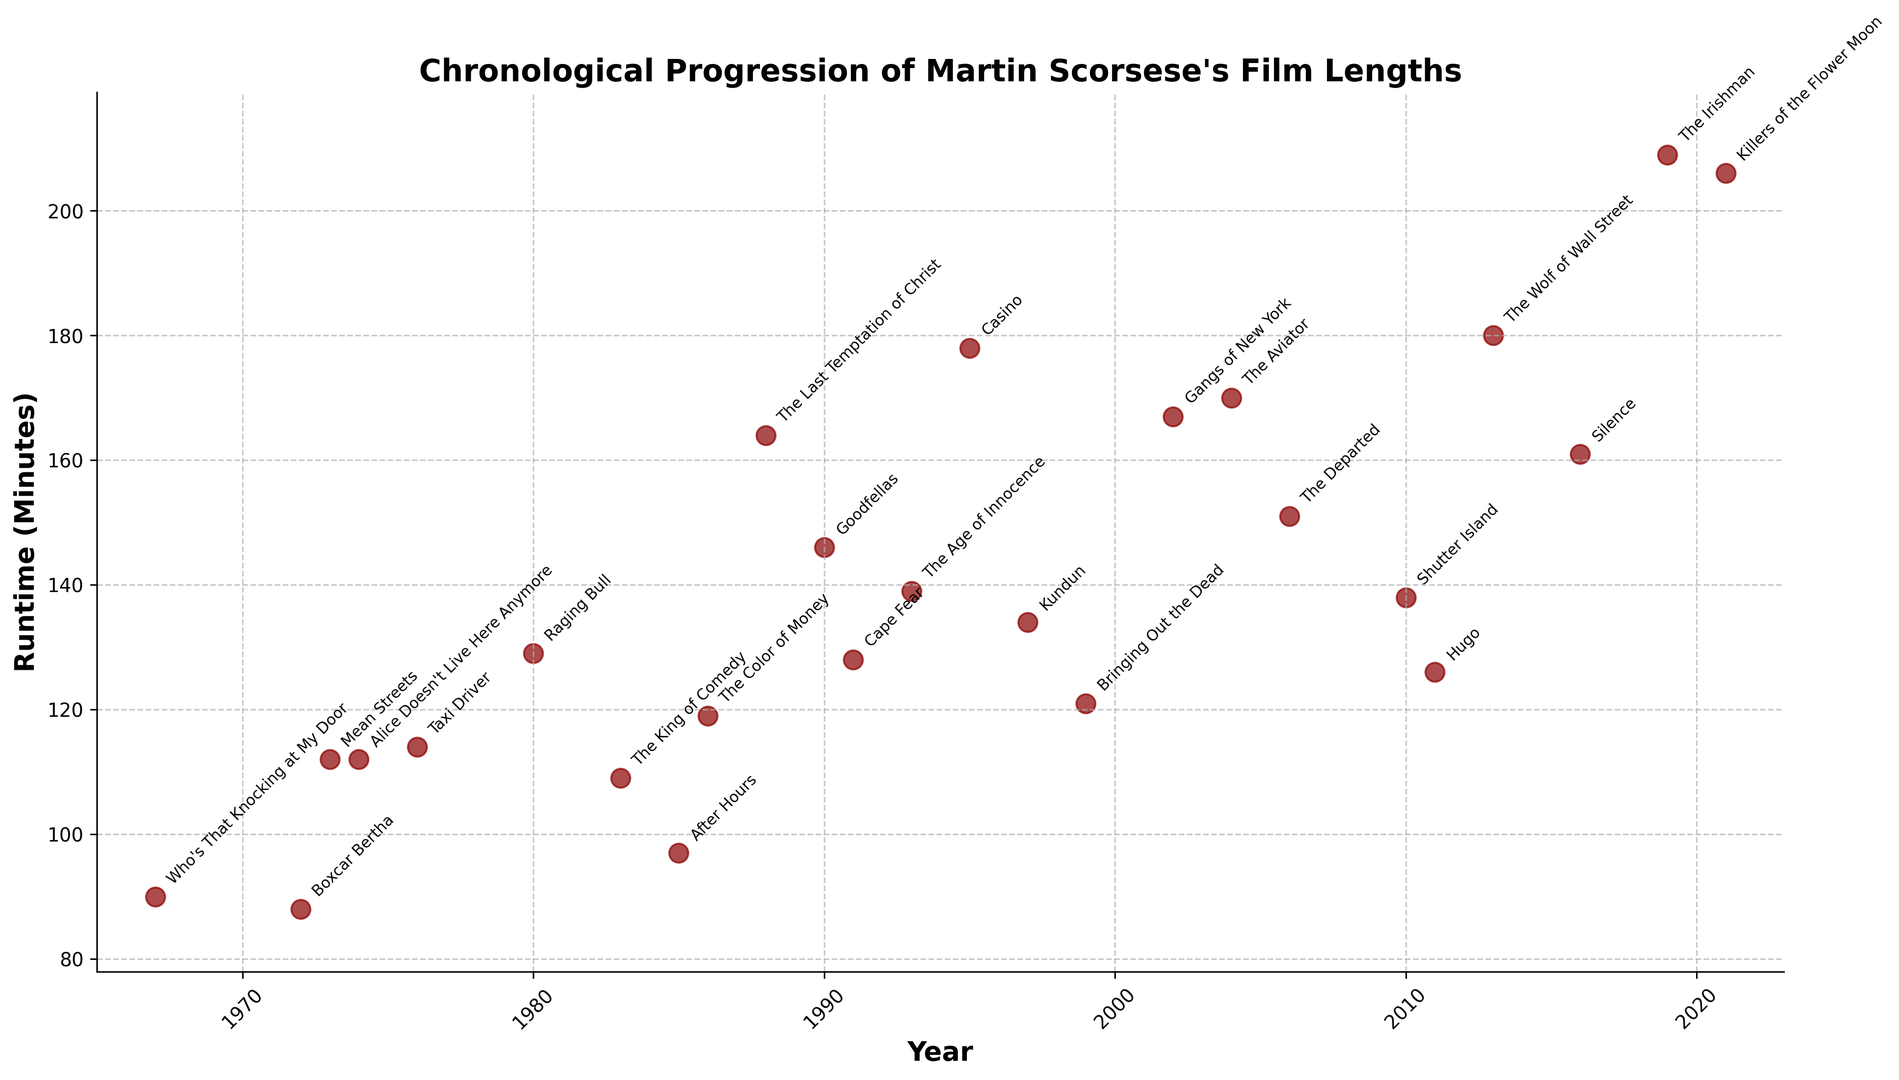Which Scorsese film has the longest runtime? Identify the tallest point on the plot corresponding to the film with the highest runtime. The film with the highest runtime is annotated as "The Irishman" with 209 minutes.
Answer: The Irishman Which film directed by Scorsese in the 1980s has the shortest runtime, and what is its duration? Look at the years in the 1980s, observe the scatter plot points in those years, and identify the shortest runtime. The film "After Hours" directed in 1985 has a runtime of 97 minutes.
Answer: After Hours, 97 minutes What is the difference in runtime between "Mean Streets" and "Taxi Driver"? Find the points corresponding to "Mean Streets" (1973) and "Taxi Driver" (1976), then subtract the former's runtime (112 minutes) from the latter's runtime (114 minutes). The difference is 2 minutes.
Answer: 2 minutes Which film has a longer runtime, "Goodfellas" or "Casino"? By how much? Identify the points corresponding to "Goodfellas" (1990) and "Casino" (1995), then compare their runtimes. "Goodfellas" has a runtime of 146 minutes, and "Casino" has 178 minutes. The difference is 32 minutes.
Answer: Casino by 32 minutes How did Scorsese's film runtimes trend from the 1990s to the 2000s? Examine the runtime points for the films from the 1990s and the 2000s. The trend shows a general increase in runtimes, with films like "Casino" (178 minutes) and "Gangs of New York" (167 minutes) compared to earlier films in the 1990s.
Answer: Increasing trend What is the average runtime of Scorsese's movies in the 2010s? Identify films released in the 2010s ("Shutter Island," "Hugo," "The Wolf of Wall Street," "Silence," and "The Irishman"), sum their runtimes (138 + 126 + 180 + 161 + 209) = 814, and divide by the number of films (5). The average is 814/5 = 162.8 minutes.
Answer: 162.8 minutes Compare the runtimes of "The Aviator" and "The Departed." Which one is longer and by how much? Find the points for "The Aviator" (2004, 170 minutes) and "The Departed" (2006, 151 minutes), compare their runtimes. The difference is 170 - 151 = 19 minutes.
Answer: The Aviator by 19 minutes Is there a film directed by Scorsese that is shorter than 100 minutes? If so, name it. Look for points with runtimes less than 100 minutes and check their annotations. The film "After Hours" (1985) has a runtime of 97 minutes.
Answer: After Hours Which decade saw the highest average runtime for Scorsese's films? Calculate the average runtime for each decade (1970s, 1980s, 1990s, 2000s, 2010s) by summing the runtimes of films from that decade and dividing by the number of films. Compare averages to find the highest one.
Answer: 2010s 